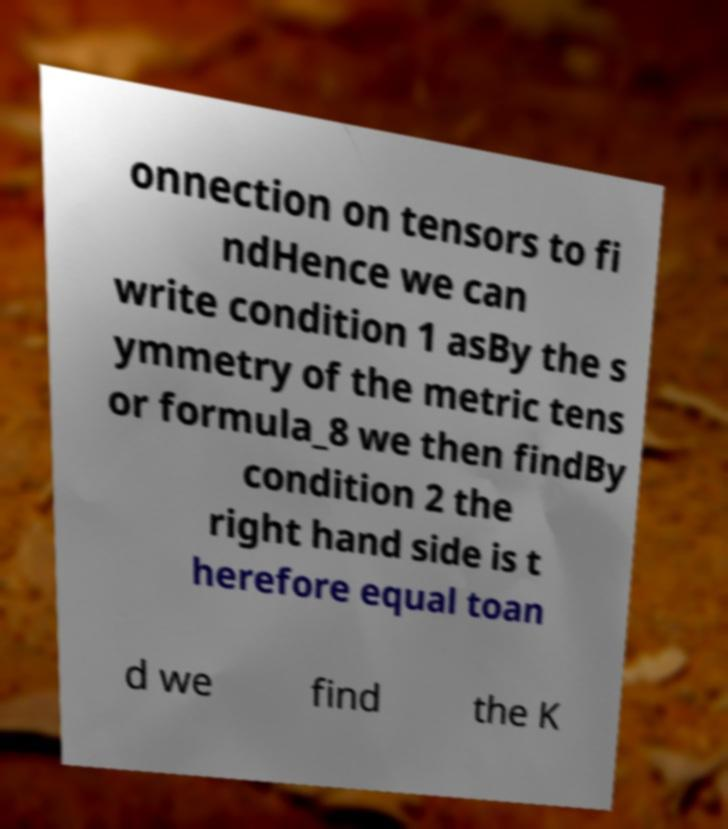What messages or text are displayed in this image? I need them in a readable, typed format. onnection on tensors to fi ndHence we can write condition 1 asBy the s ymmetry of the metric tens or formula_8 we then findBy condition 2 the right hand side is t herefore equal toan d we find the K 